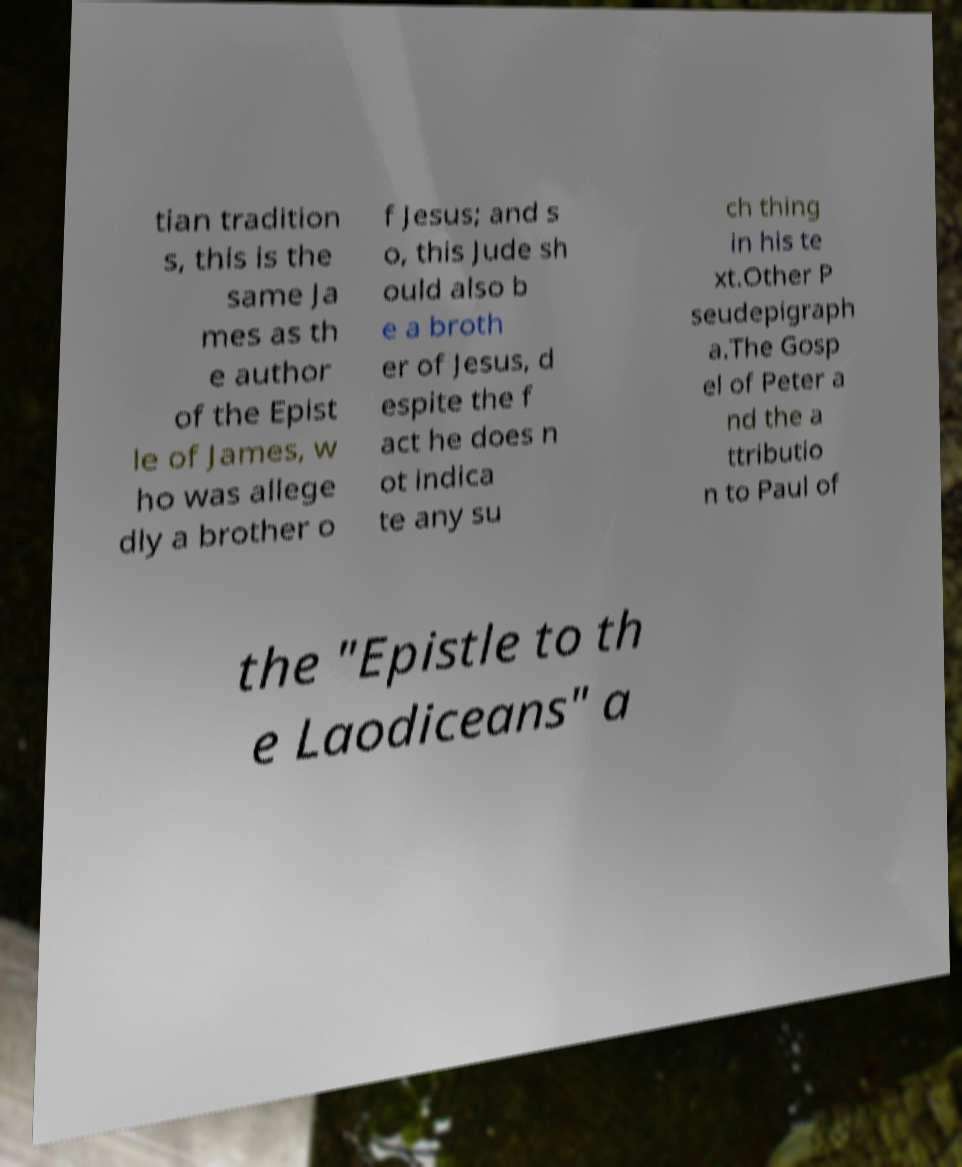Could you assist in decoding the text presented in this image and type it out clearly? tian tradition s, this is the same Ja mes as th e author of the Epist le of James, w ho was allege dly a brother o f Jesus; and s o, this Jude sh ould also b e a broth er of Jesus, d espite the f act he does n ot indica te any su ch thing in his te xt.Other P seudepigraph a.The Gosp el of Peter a nd the a ttributio n to Paul of the "Epistle to th e Laodiceans" a 